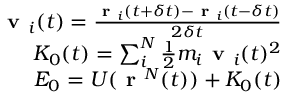Convert formula to latex. <formula><loc_0><loc_0><loc_500><loc_500>\begin{array} { r } { v _ { i } ( t ) = \frac { r _ { i } ( t + \delta t ) - r _ { i } ( t - \delta t ) } { 2 \delta t } } \\ { K _ { 0 } ( t ) = \sum _ { i } ^ { N } \frac { 1 } { 2 } m _ { i } v _ { i } ( t ) ^ { 2 } } \\ { E _ { 0 } = U ( r ^ { N } ( t ) ) + K _ { 0 } ( t ) } \end{array}</formula> 